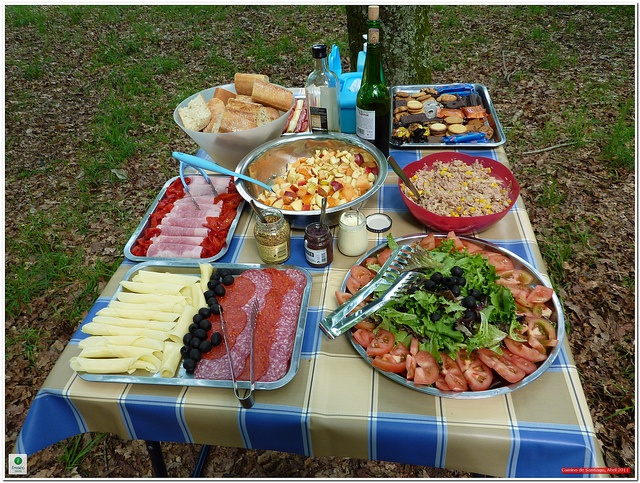Describe the objects in this image and their specific colors. I can see dining table in white, darkgray, black, beige, and tan tones, bowl in white, khaki, tan, and olive tones, bowl in white, brown, and tan tones, bowl in white, darkgray, gray, and tan tones, and bottle in white, black, darkgray, darkgreen, and gray tones in this image. 